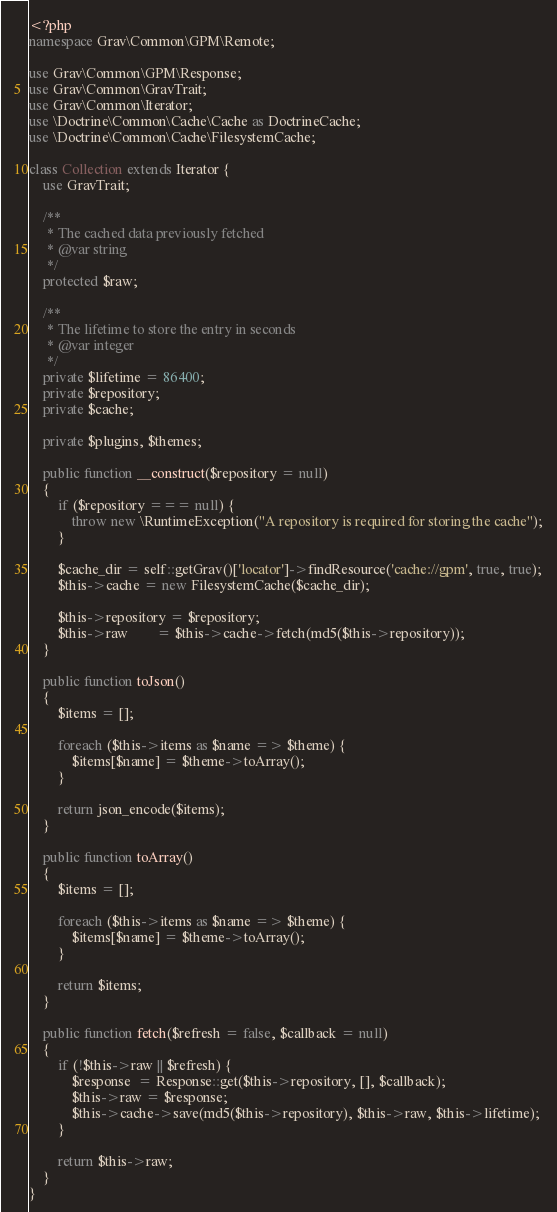<code> <loc_0><loc_0><loc_500><loc_500><_PHP_><?php
namespace Grav\Common\GPM\Remote;

use Grav\Common\GPM\Response;
use Grav\Common\GravTrait;
use Grav\Common\Iterator;
use \Doctrine\Common\Cache\Cache as DoctrineCache;
use \Doctrine\Common\Cache\FilesystemCache;

class Collection extends Iterator {
    use GravTrait;

    /**
     * The cached data previously fetched
     * @var string
     */
    protected $raw;

    /**
     * The lifetime to store the entry in seconds
     * @var integer
     */
    private $lifetime = 86400;
    private $repository;
    private $cache;

    private $plugins, $themes;

    public function __construct($repository = null)
    {
        if ($repository === null) {
            throw new \RuntimeException("A repository is required for storing the cache");
        }

        $cache_dir = self::getGrav()['locator']->findResource('cache://gpm', true, true);
        $this->cache = new FilesystemCache($cache_dir);

        $this->repository = $repository;
        $this->raw        = $this->cache->fetch(md5($this->repository));
    }

    public function toJson()
    {
        $items = [];

        foreach ($this->items as $name => $theme) {
            $items[$name] = $theme->toArray();
        }

        return json_encode($items);
    }

    public function toArray()
    {
        $items = [];

        foreach ($this->items as $name => $theme) {
            $items[$name] = $theme->toArray();
        }

        return $items;
    }

    public function fetch($refresh = false, $callback = null)
    {
        if (!$this->raw || $refresh) {
            $response  = Response::get($this->repository, [], $callback);
            $this->raw = $response;
            $this->cache->save(md5($this->repository), $this->raw, $this->lifetime);
        }

        return $this->raw;
    }
}
</code> 